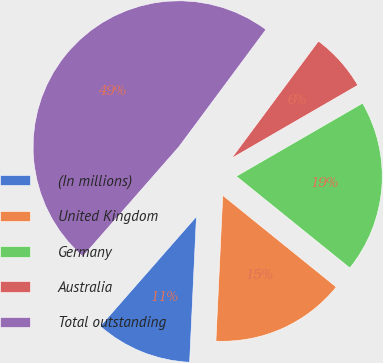<chart> <loc_0><loc_0><loc_500><loc_500><pie_chart><fcel>(In millions)<fcel>United Kingdom<fcel>Germany<fcel>Australia<fcel>Total outstanding<nl><fcel>10.71%<fcel>14.93%<fcel>19.16%<fcel>6.49%<fcel>48.7%<nl></chart> 